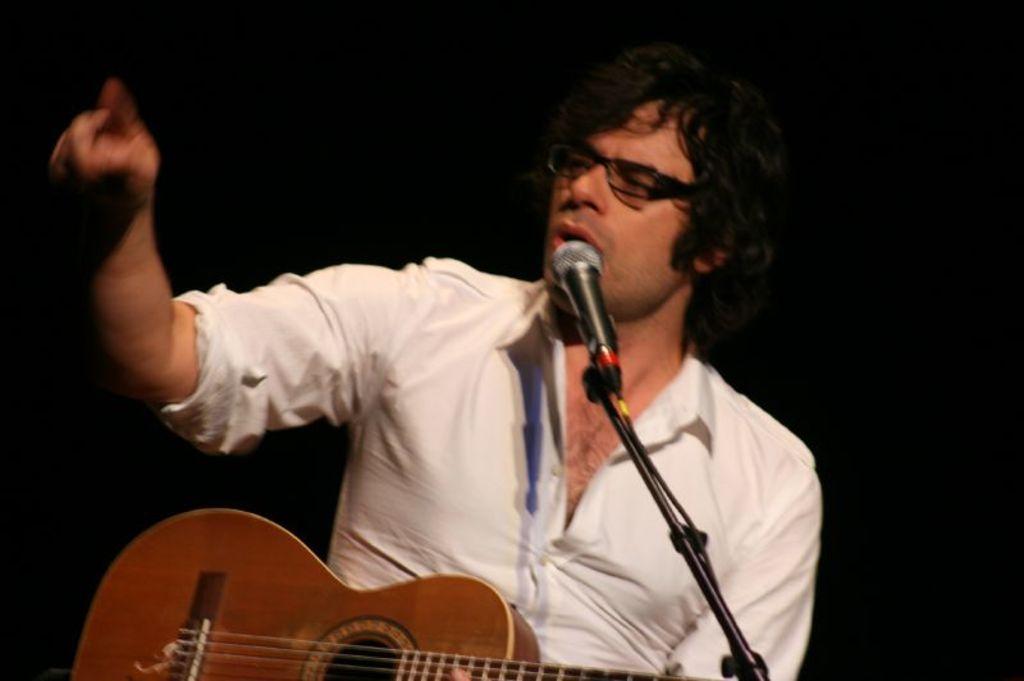Please provide a concise description of this image. In this image there is one person who is holding a guitar, in front of him there is one mike it seems that he is singing. 